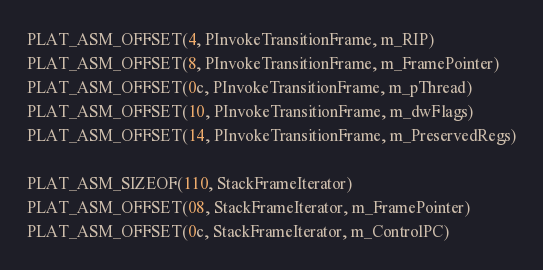<code> <loc_0><loc_0><loc_500><loc_500><_C_>PLAT_ASM_OFFSET(4, PInvokeTransitionFrame, m_RIP)
PLAT_ASM_OFFSET(8, PInvokeTransitionFrame, m_FramePointer)
PLAT_ASM_OFFSET(0c, PInvokeTransitionFrame, m_pThread)
PLAT_ASM_OFFSET(10, PInvokeTransitionFrame, m_dwFlags)
PLAT_ASM_OFFSET(14, PInvokeTransitionFrame, m_PreservedRegs)

PLAT_ASM_SIZEOF(110, StackFrameIterator)
PLAT_ASM_OFFSET(08, StackFrameIterator, m_FramePointer)
PLAT_ASM_OFFSET(0c, StackFrameIterator, m_ControlPC)</code> 